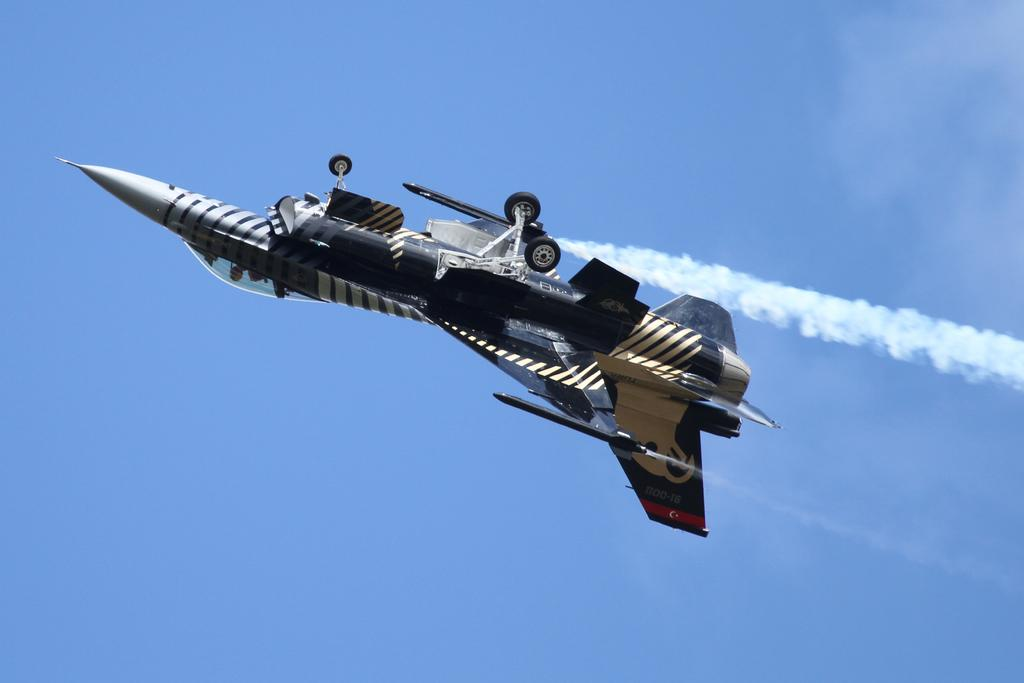What is the main subject of the image? The main subject of the image is a jet plane. What is the jet plane doing in the image? The jet plane is flying in the sky. What can be seen coming out of the jet plane? There is smoke visible in the image. What part of the jet plane is designed for landing? The jet plane has wheels attached to it. Can you tell me what time it is according to the clocks in the image? There are no clocks present in the image, so it is not possible to determine the time. 